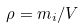<formula> <loc_0><loc_0><loc_500><loc_500>\rho = m _ { i } / V</formula> 